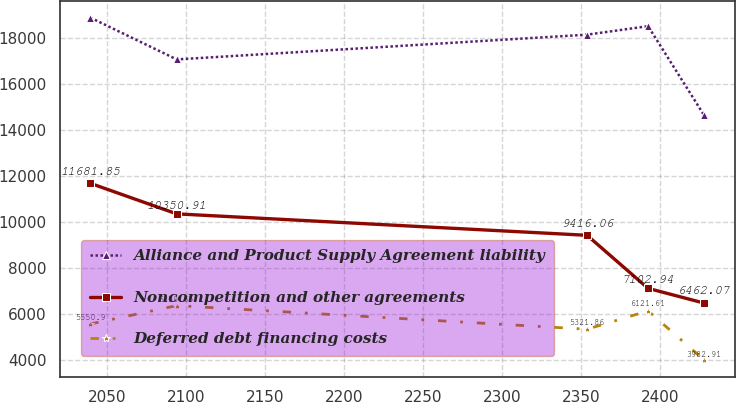Convert chart. <chart><loc_0><loc_0><loc_500><loc_500><line_chart><ecel><fcel>Alliance and Product Supply Agreement liability<fcel>Noncompetition and other agreements<fcel>Deferred debt financing costs<nl><fcel>2039.29<fcel>18905.1<fcel>11681.9<fcel>5550.9<nl><fcel>2093.95<fcel>17084.6<fcel>10350.9<fcel>6350.65<nl><fcel>2353.71<fcel>18163.1<fcel>9416.06<fcel>5321.86<nl><fcel>2392.34<fcel>18534.1<fcel>7102.94<fcel>6121.61<nl><fcel>2427.75<fcel>14655.5<fcel>6462.07<fcel>3982.91<nl></chart> 